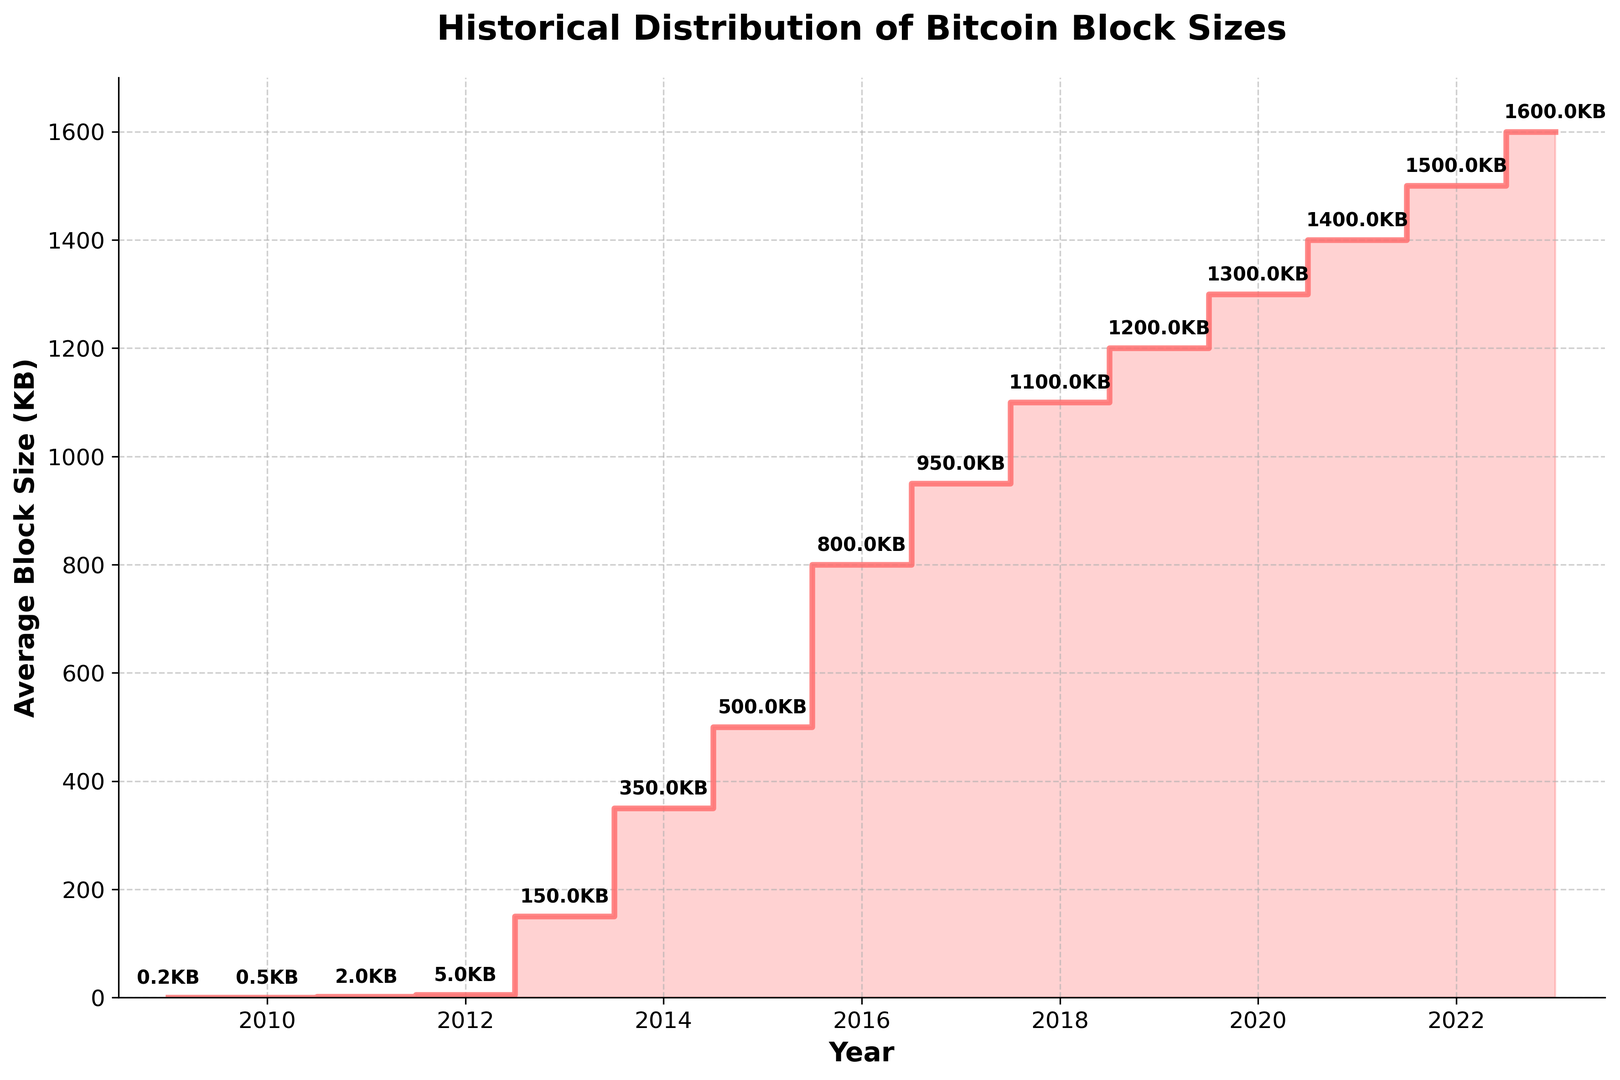What's the average Bitcoin block size in the year 2015? To find the average Bitcoin block size in 2015, look for the data corresponding to the year 2015 on the x-axis and read the value on the y-axis. The block size for 2015 is 500 KB.
Answer: 500 KB How much did the average Bitcoin block size increase from 2013 to 2014? Find the block sizes for both 2013 and 2014 on the y-axis. The block size was 150 KB in 2013 and 350 KB in 2014. Subtract the 2013 value from the 2014 value. 350 KB - 150 KB = 200 KB
Answer: 200 KB In which year did the average Bitcoin block size first cross 1000 KB? Look for the first instance on the x-axis where the value on the y-axis exceeds 1000 KB. It first occurs in 2018.
Answer: 2018 What's the difference in average Bitcoin block size between the year 2021 and the year 2019? Find the block sizes for the years 2021 and 2019 on the y-axis. The block size was 1400 KB in 2021 and 1200 KB in 2019. Subtract the 2019 value from the 2021 value. 1400 KB - 1200 KB = 200 KB
Answer: 200 KB Which year showed the greatest increase in average Bitcoin block size from the previous year? Calculate the year-on-year differences and identify the greatest one. From 2012 to 2013: 150-5=145 KB, from 2013 to 2014: 350-150=200 KB, from 2014 to 2015: 500-350=150 KB, and so on. The largest increase is 200 KB from 2013 to 2014.
Answer: 2014 What is the trend of average Bitcoin block size from 2016 to 2018? Look at the y-axis values for the years 2016, 2017, and 2018. They are 800 KB, 950 KB, and 1100 KB, respectively, showing a steady increase each year.
Answer: Increasing By how much has the average Bitcoin block size grown from 2009 to 2023? Subtract the block size in 2009 from the block size in 2023. The block size was 0.2 KB in 2009 and 1600 KB in 2023. Therefore, 1600 KB - 0.2 KB = 1599.8 KB
Answer: 1599.8 KB Which years show a block size greater than or equal to 1000 KB? Identify all the years along the x-axis where the y-axis value is greater than or equal to 1000 KB. These years are 2018, 2019, 2020, 2021, 2022, and 2023.
Answer: 2018, 2019, 2020, 2021, 2022, 2023 What average block size value is specifically highlighted for the year 2017? Look for the labeled block size value on the plot corresponding to the year 2017. It is highlighted as 950 KB.
Answer: 950 KB 